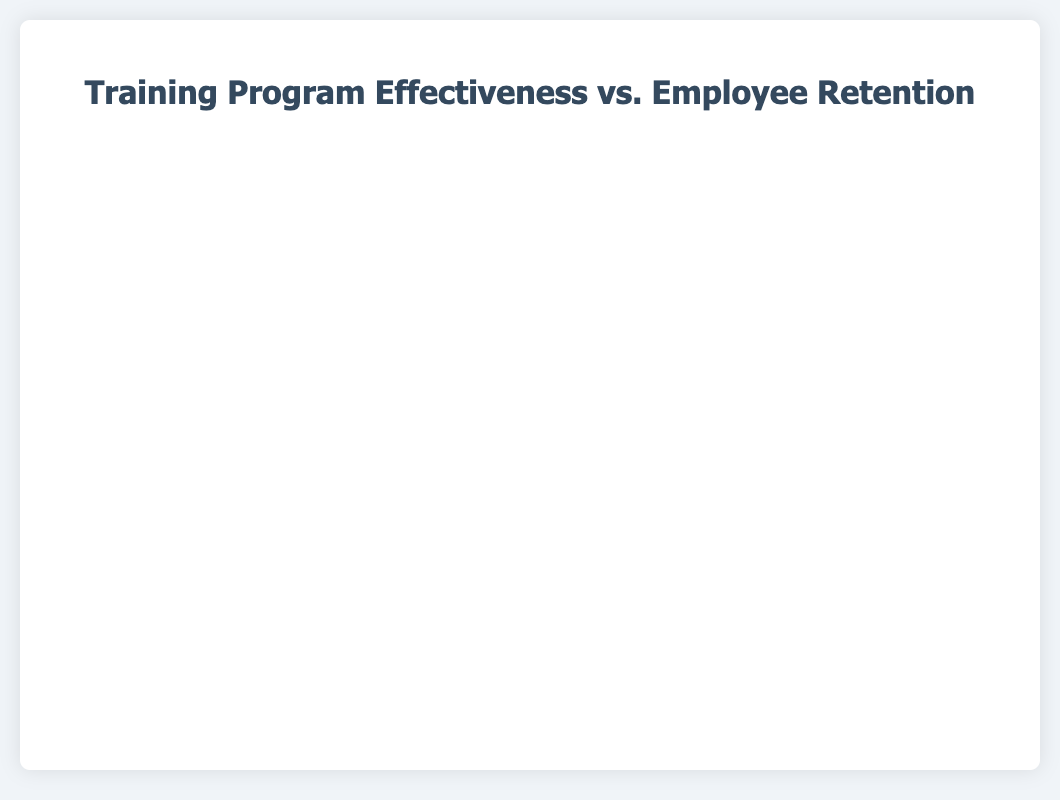What's the title of the figure? The title of the figure is indicated at the top of the chart.
Answer: Training Program Effectiveness vs. Employee Retention Which training program has the highest employee retention rate? The training program positioned at the highest point on the Y-axis represents the highest employee retention rate. In this case, it is ‘Cybersecurity Awareness' with a retention rate of 92%.
Answer: Cybersecurity Awareness How many training programs are represented in the chart? The number of distinct data points (bubbles) in the chart corresponds to the number of training programs. There are seven bubbles representing seven programs.
Answer: 7 What’s the average tenure of employees who underwent the 'Technical Skills Enhancement' program? The size of the bubble indicates the average tenure for each program. The 'Technical Skills Enhancement' bubble has an average tenure (radius) of 40 months.
Answer: 40 months Which training programs have an effectiveness score above 80? Effectiveness scores are shown along the X-axis. By inspecting bubbles with X-values greater than 80, we find ‘Technical Skills Enhancement’, ‘Cybersecurity Awareness', and 'Data Analytics’.
Answer: Technical Skills Enhancement, Cybersecurity Awareness, Data Analytics Compare the employee retention rates between 'Leadership Development' and 'Customer Service Training'. Which one is higher and by how much? Locate the Y-values for both training programs. 'Leadership Development' has a retention rate of 85%, and 'Customer Service Training' has 80%. The difference is 85% - 80% = 5%.
Answer: Leadership Development is higher by 5% If we were to calculate the effectiveness-to-retention ratio, which program has the highest ratio? The ratio is calculated as Effectiveness Score/Employee Retention Rate. For 'Cybersecurity Awareness’: 85/92 ≈ 0.92, 'Data Analytics': 81/89 ≈ 0.91, etc. ‘Leadership Development’: 78/85 ≈ 0.92. By computing each ratio, ‘Cybersecurity Awareness’ and 'Leadership Development' have the highest ratios, both approximately 0.92.
Answer: Cybersecurity Awareness and Leadership Development Which training program has the lowest effectiveness score, and what is it? The bubble with the smallest X-value represents the lowest effectiveness score. 'Sales Techniques' has the lowest score of 72.
Answer: Sales Techniques, 72 What’s the combined average tenure of employees for 'Project Management' and 'Data Analytics' programs? Add the average tenures (radius values) of both programs: 42 (Project Management) + 45 (Data Analytics) = 87 months.
Answer: 87 months Which training program has the highest average tenure, and does it coincide with the highest retention rate? The size of each bubble indicates the average tenure. 'Cybersecurity Awareness' has the largest bubble (radius = 48) and also has the highest retention rate (92%).
Answer: Cybersecurity Awareness, yes 